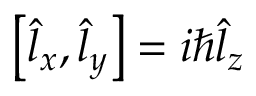<formula> <loc_0><loc_0><loc_500><loc_500>\begin{array} { r } { \left [ \hat { l } _ { x } , \hat { l } _ { y } \right ] = i \hbar { \hat } { l } _ { z } } \end{array}</formula> 